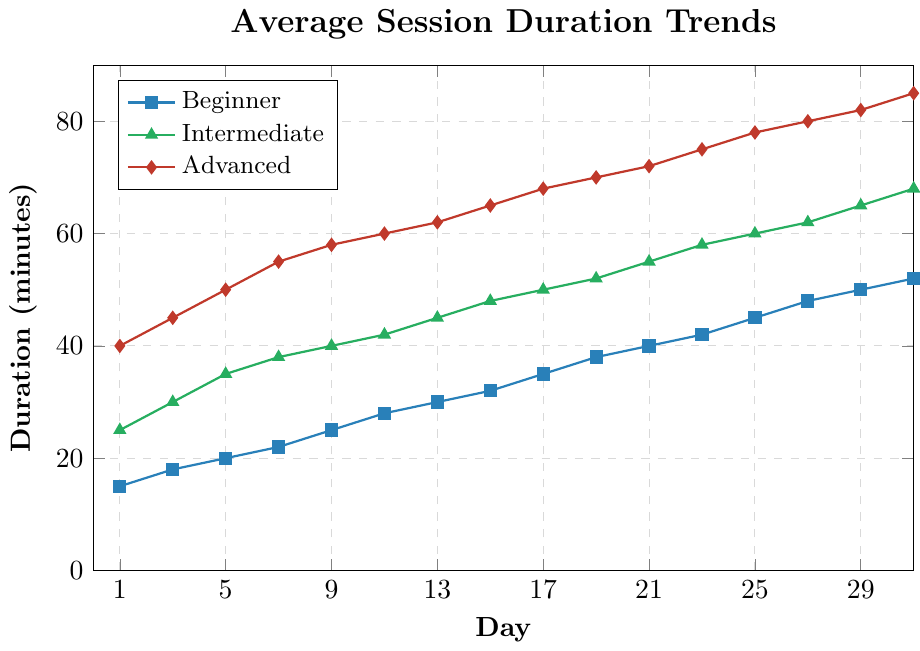What's the average session duration for Intermediate players on Day 9 and Day 17? To find the average, sum the durations for Intermediate players on Day 9 (40 minutes) and Day 17 (50 minutes), then divide by 2. So, (40 + 50) / 2 = 45.
Answer: 45 Which player experience level showed the highest session duration on Day 7? Compare the session durations for all levels on Day 7: Beginner (22 minutes), Intermediate (38 minutes), Advanced (55 minutes). The highest value is 55 minutes for Advanced players.
Answer: Advanced What is the difference in session duration between Beginner and Advanced players on Day 25? To find the difference, subtract the Beginner duration on Day 25 (45 minutes) from the Advanced duration on the same day (78 minutes): 78 - 45 = 33.
Answer: 33 On which day did Beginner players first reach a session duration of 40 minutes? Locate the day where the session duration for Beginner players is exactly 40 minutes. This happens on Day 21.
Answer: 21 How much did the session duration for Advanced players increase from Day 1 to Day 31? Subtract the session duration on Day 1 (40 minutes) from the duration on Day 31 (85 minutes): 85 - 40 = 45.
Answer: 45 Compare the session duration trends for Beginner and Intermediate players: which player level always had higher values? Compare the session durations for each day between Beginner and Intermediate players. The Intermediate level consistently has higher values throughout all the days.
Answer: Intermediate What is the total increase in session duration for Beginner players from Day 1 to Day 15? Calculate the increase step-by-step: Day 1 (15 minutes) to Day 15 (32 minutes). The increase is 32 - 15 = 17 minutes.
Answer: 17 What can you observe about the trend lines for all three player levels? Describe the trend lines: All three player levels show an upward trend in session duration over time, with Advanced players having the steepest increase.
Answer: Upward trend for all; steepest for Advanced If you consider the midpoint of the testing period (Day 16), what were the session durations for each player level and which had the median value? Check Day 15 and 17 for midpoint approximation: Beginner (32 minutes on Day 15, 35 on Day 17), Intermediate (48 on Day 15, 50 on Day 17), Advanced (65 on Day 15, 68 on Day 17). Median values are Intermediate at around 49 minutes.
Answer: Intermediate 